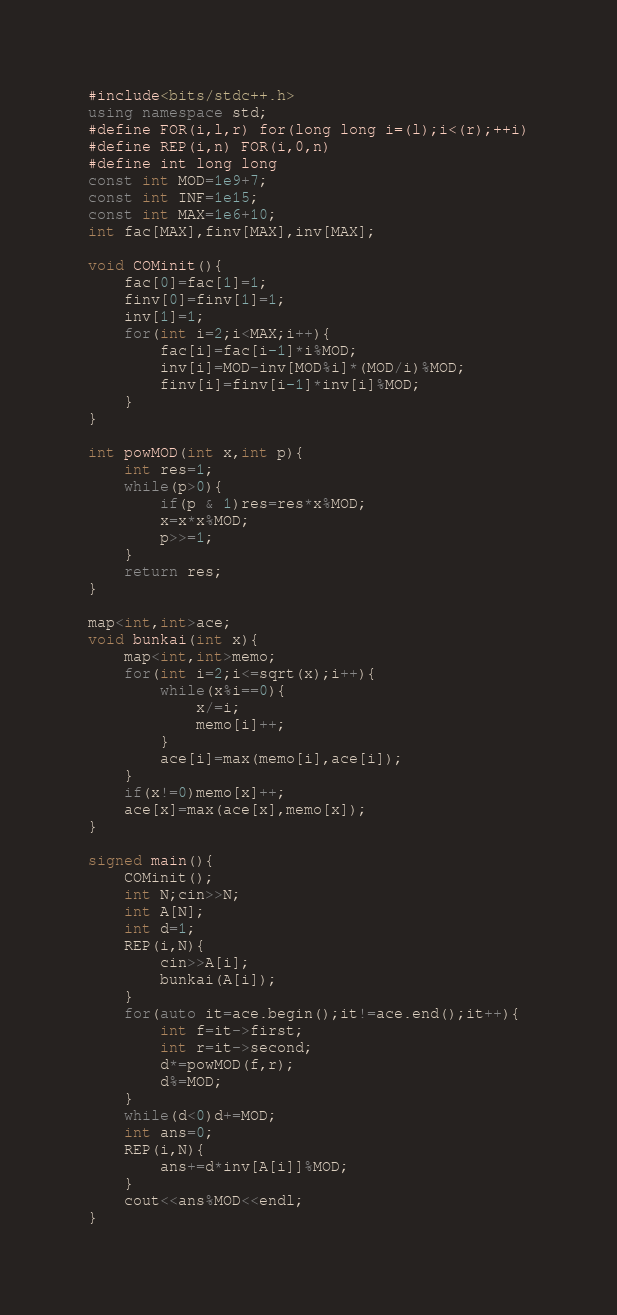<code> <loc_0><loc_0><loc_500><loc_500><_C++_>#include<bits/stdc++.h>
using namespace std;
#define FOR(i,l,r) for(long long i=(l);i<(r);++i)
#define REP(i,n) FOR(i,0,n)
#define int long long
const int MOD=1e9+7;
const int INF=1e15;
const int MAX=1e6+10;
int fac[MAX],finv[MAX],inv[MAX];

void COMinit(){
    fac[0]=fac[1]=1;
    finv[0]=finv[1]=1;
    inv[1]=1;
    for(int i=2;i<MAX;i++){
        fac[i]=fac[i-1]*i%MOD;
        inv[i]=MOD-inv[MOD%i]*(MOD/i)%MOD;
        finv[i]=finv[i-1]*inv[i]%MOD;
    }
}

int powMOD(int x,int p){
  	int res=1;
    while(p>0){
        if(p & 1)res=res*x%MOD;
        x=x*x%MOD;
        p>>=1;
    }
    return res;
}

map<int,int>ace;
void bunkai(int x){
    map<int,int>memo;
    for(int i=2;i<=sqrt(x);i++){
        while(x%i==0){
            x/=i;
            memo[i]++;
        }
        ace[i]=max(memo[i],ace[i]);
    }
    if(x!=0)memo[x]++;
    ace[x]=max(ace[x],memo[x]);
}

signed main(){
    COMinit();
  	int N;cin>>N;
    int A[N];
    int d=1;
    REP(i,N){
        cin>>A[i];
        bunkai(A[i]);
    }
    for(auto it=ace.begin();it!=ace.end();it++){
        int f=it->first;
        int r=it->second;
        d*=powMOD(f,r);
        d%=MOD;
    }
    while(d<0)d+=MOD;
  	int ans=0;
    REP(i,N){
        ans+=d*inv[A[i]]%MOD;
    }
    cout<<ans%MOD<<endl;
}</code> 